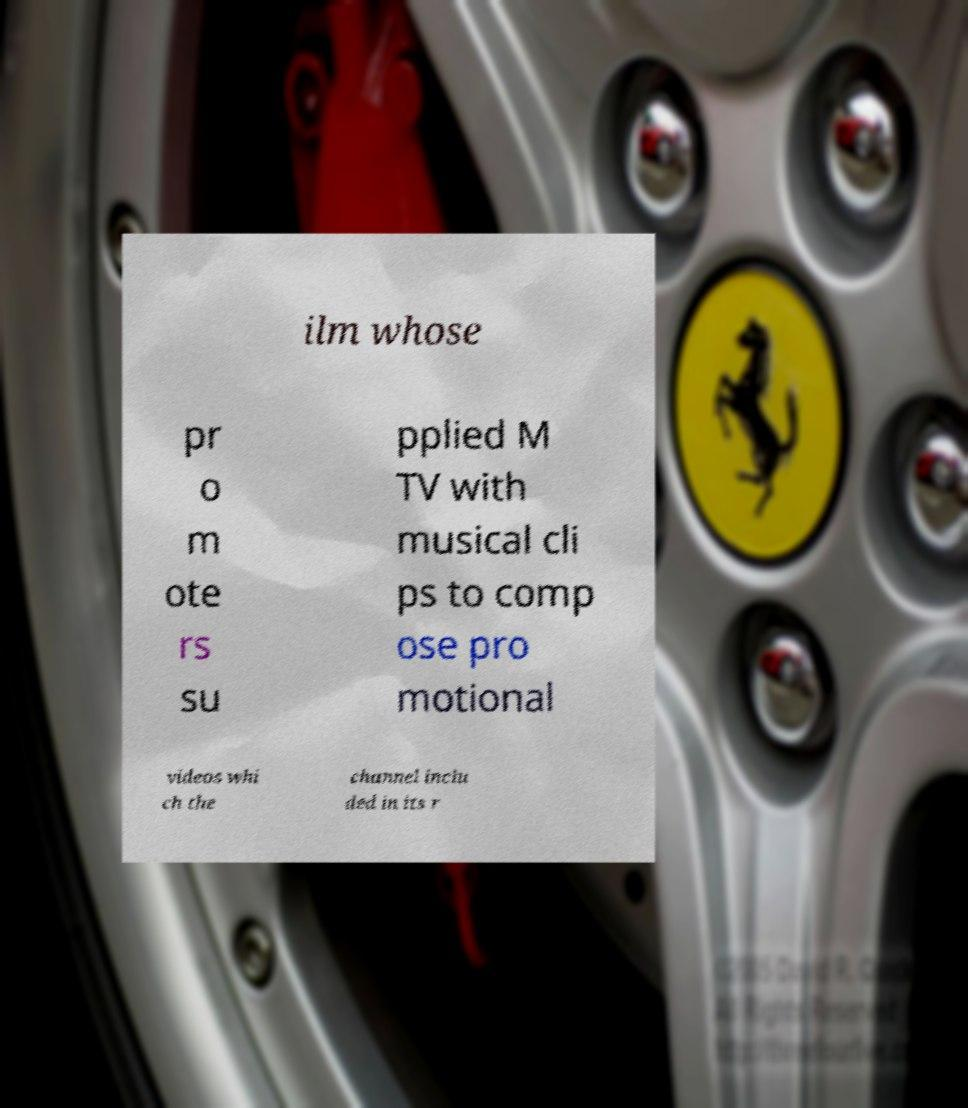Please read and relay the text visible in this image. What does it say? ilm whose pr o m ote rs su pplied M TV with musical cli ps to comp ose pro motional videos whi ch the channel inclu ded in its r 